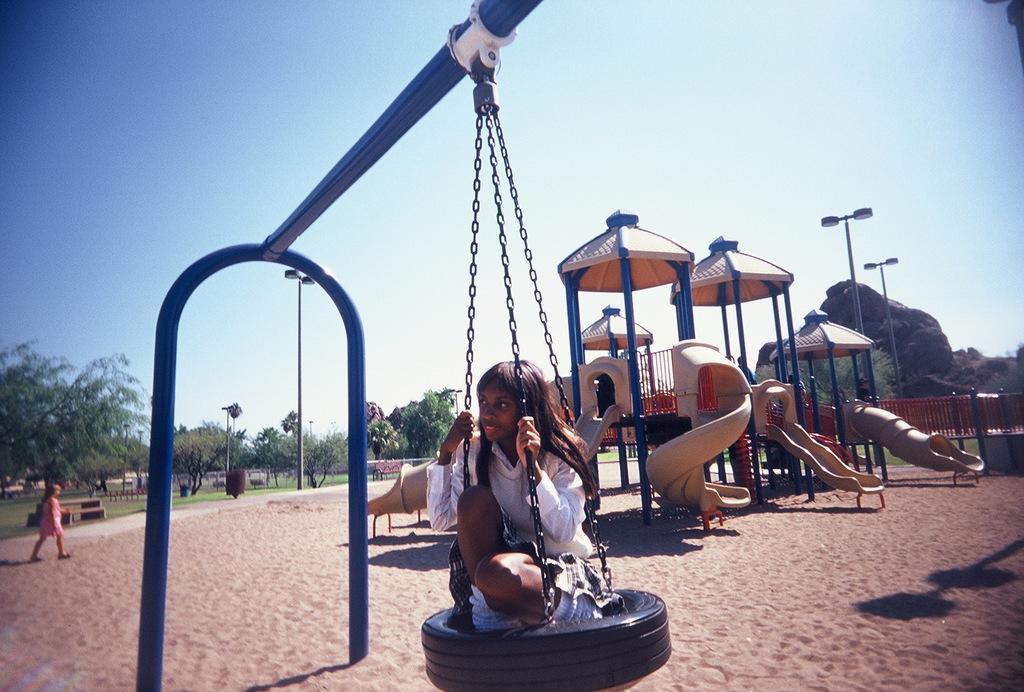In one or two sentences, can you explain what this image depicts? This image is clicked outside. There are so many trees on the left side. There is sky at the top. There is one child in the middle, she is sitting on a swing. There is another child on the left side. There are so many playing equipments. 